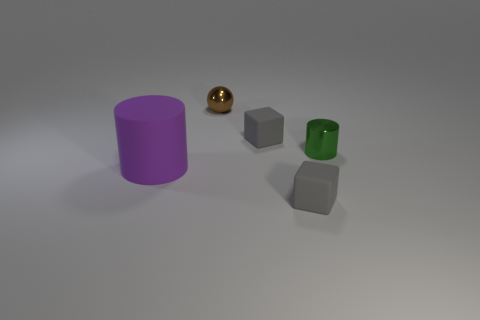There is another thing that is the same shape as the large thing; what color is it?
Provide a short and direct response. Green. What size is the thing that is right of the brown metal ball and behind the tiny green metal object?
Your answer should be compact. Small. How many purple rubber cylinders are there?
Provide a short and direct response. 1. There is a green cylinder that is the same size as the brown shiny object; what material is it?
Offer a very short reply. Metal. Are there any brown metal balls of the same size as the green thing?
Give a very brief answer. Yes. Does the matte object behind the small green thing have the same color as the matte thing in front of the large matte object?
Offer a terse response. Yes. What number of matte things are brown things or big purple cylinders?
Offer a very short reply. 1. There is a block that is behind the shiny object in front of the tiny brown metal sphere; how many objects are behind it?
Provide a succinct answer. 1. There is a object on the left side of the brown ball; does it have the same size as the brown metal ball?
Provide a succinct answer. No. What number of objects are brown things or rubber objects on the right side of the large purple cylinder?
Your response must be concise. 3. 